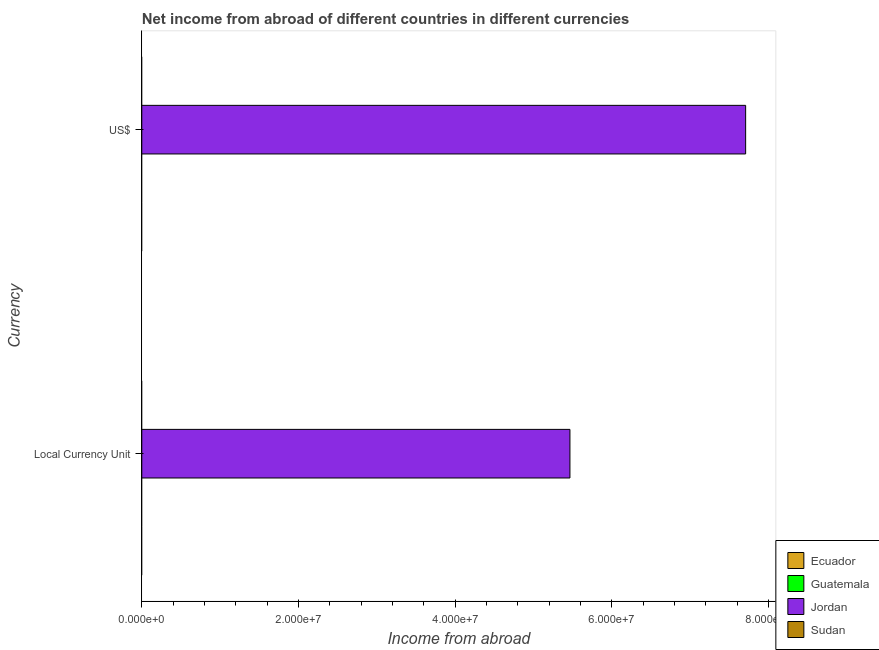How many different coloured bars are there?
Make the answer very short. 1. How many bars are there on the 2nd tick from the top?
Provide a short and direct response. 1. How many bars are there on the 1st tick from the bottom?
Offer a very short reply. 1. What is the label of the 1st group of bars from the top?
Make the answer very short. US$. Across all countries, what is the maximum income from abroad in constant 2005 us$?
Keep it short and to the point. 5.47e+07. Across all countries, what is the minimum income from abroad in constant 2005 us$?
Ensure brevity in your answer.  0. In which country was the income from abroad in us$ maximum?
Provide a short and direct response. Jordan. What is the total income from abroad in us$ in the graph?
Offer a terse response. 7.71e+07. What is the average income from abroad in us$ per country?
Offer a terse response. 1.93e+07. What is the difference between the income from abroad in us$ and income from abroad in constant 2005 us$ in Jordan?
Offer a very short reply. 2.24e+07. In how many countries, is the income from abroad in us$ greater than the average income from abroad in us$ taken over all countries?
Provide a short and direct response. 1. How many bars are there?
Your response must be concise. 2. How many countries are there in the graph?
Make the answer very short. 4. Are the values on the major ticks of X-axis written in scientific E-notation?
Ensure brevity in your answer.  Yes. Does the graph contain any zero values?
Your answer should be very brief. Yes. How are the legend labels stacked?
Offer a very short reply. Vertical. What is the title of the graph?
Provide a short and direct response. Net income from abroad of different countries in different currencies. What is the label or title of the X-axis?
Offer a very short reply. Income from abroad. What is the label or title of the Y-axis?
Your answer should be very brief. Currency. What is the Income from abroad in Jordan in Local Currency Unit?
Keep it short and to the point. 5.47e+07. What is the Income from abroad in Sudan in Local Currency Unit?
Your answer should be very brief. 0. What is the Income from abroad of Ecuador in US$?
Give a very brief answer. 0. What is the Income from abroad in Guatemala in US$?
Ensure brevity in your answer.  0. What is the Income from abroad of Jordan in US$?
Offer a very short reply. 7.71e+07. Across all Currency, what is the maximum Income from abroad of Jordan?
Offer a very short reply. 7.71e+07. Across all Currency, what is the minimum Income from abroad in Jordan?
Your response must be concise. 5.47e+07. What is the total Income from abroad of Jordan in the graph?
Your answer should be compact. 1.32e+08. What is the difference between the Income from abroad of Jordan in Local Currency Unit and that in US$?
Your answer should be compact. -2.24e+07. What is the average Income from abroad in Ecuador per Currency?
Keep it short and to the point. 0. What is the average Income from abroad of Jordan per Currency?
Make the answer very short. 6.59e+07. What is the average Income from abroad in Sudan per Currency?
Offer a terse response. 0. What is the ratio of the Income from abroad of Jordan in Local Currency Unit to that in US$?
Ensure brevity in your answer.  0.71. What is the difference between the highest and the second highest Income from abroad in Jordan?
Give a very brief answer. 2.24e+07. What is the difference between the highest and the lowest Income from abroad in Jordan?
Keep it short and to the point. 2.24e+07. 